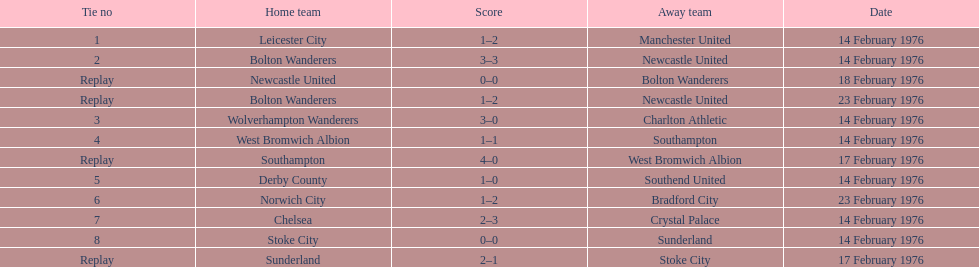What is the difference between southampton's score and sunderland's score? 2 goals. Could you help me parse every detail presented in this table? {'header': ['Tie no', 'Home team', 'Score', 'Away team', 'Date'], 'rows': [['1', 'Leicester City', '1–2', 'Manchester United', '14 February 1976'], ['2', 'Bolton Wanderers', '3–3', 'Newcastle United', '14 February 1976'], ['Replay', 'Newcastle United', '0–0', 'Bolton Wanderers', '18 February 1976'], ['Replay', 'Bolton Wanderers', '1–2', 'Newcastle United', '23 February 1976'], ['3', 'Wolverhampton Wanderers', '3–0', 'Charlton Athletic', '14 February 1976'], ['4', 'West Bromwich Albion', '1–1', 'Southampton', '14 February 1976'], ['Replay', 'Southampton', '4–0', 'West Bromwich Albion', '17 February 1976'], ['5', 'Derby County', '1–0', 'Southend United', '14 February 1976'], ['6', 'Norwich City', '1–2', 'Bradford City', '23 February 1976'], ['7', 'Chelsea', '2–3', 'Crystal Palace', '14 February 1976'], ['8', 'Stoke City', '0–0', 'Sunderland', '14 February 1976'], ['Replay', 'Sunderland', '2–1', 'Stoke City', '17 February 1976']]} 